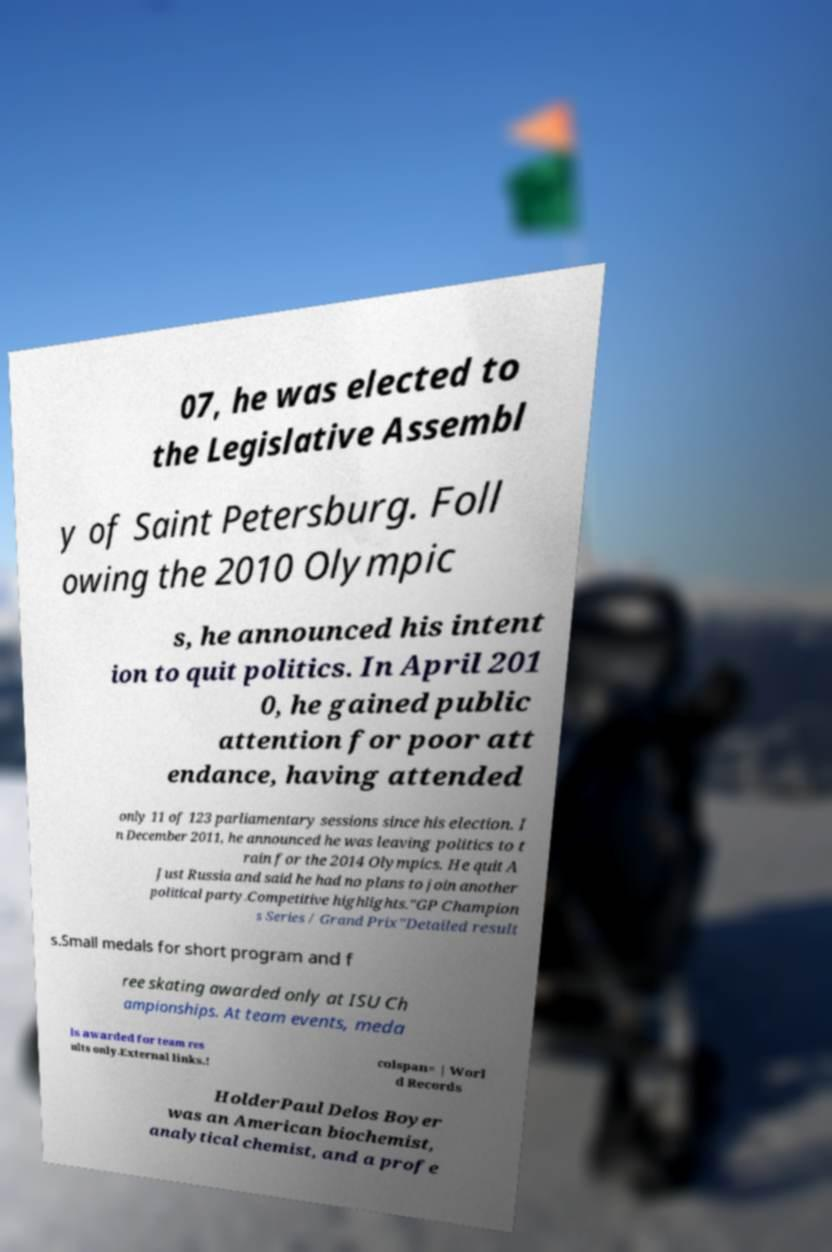Please read and relay the text visible in this image. What does it say? 07, he was elected to the Legislative Assembl y of Saint Petersburg. Foll owing the 2010 Olympic s, he announced his intent ion to quit politics. In April 201 0, he gained public attention for poor att endance, having attended only 11 of 123 parliamentary sessions since his election. I n December 2011, he announced he was leaving politics to t rain for the 2014 Olympics. He quit A Just Russia and said he had no plans to join another political party.Competitive highlights."GP Champion s Series / Grand Prix"Detailed result s.Small medals for short program and f ree skating awarded only at ISU Ch ampionships. At team events, meda ls awarded for team res ults only.External links.! colspan= | Worl d Records HolderPaul Delos Boyer was an American biochemist, analytical chemist, and a profe 